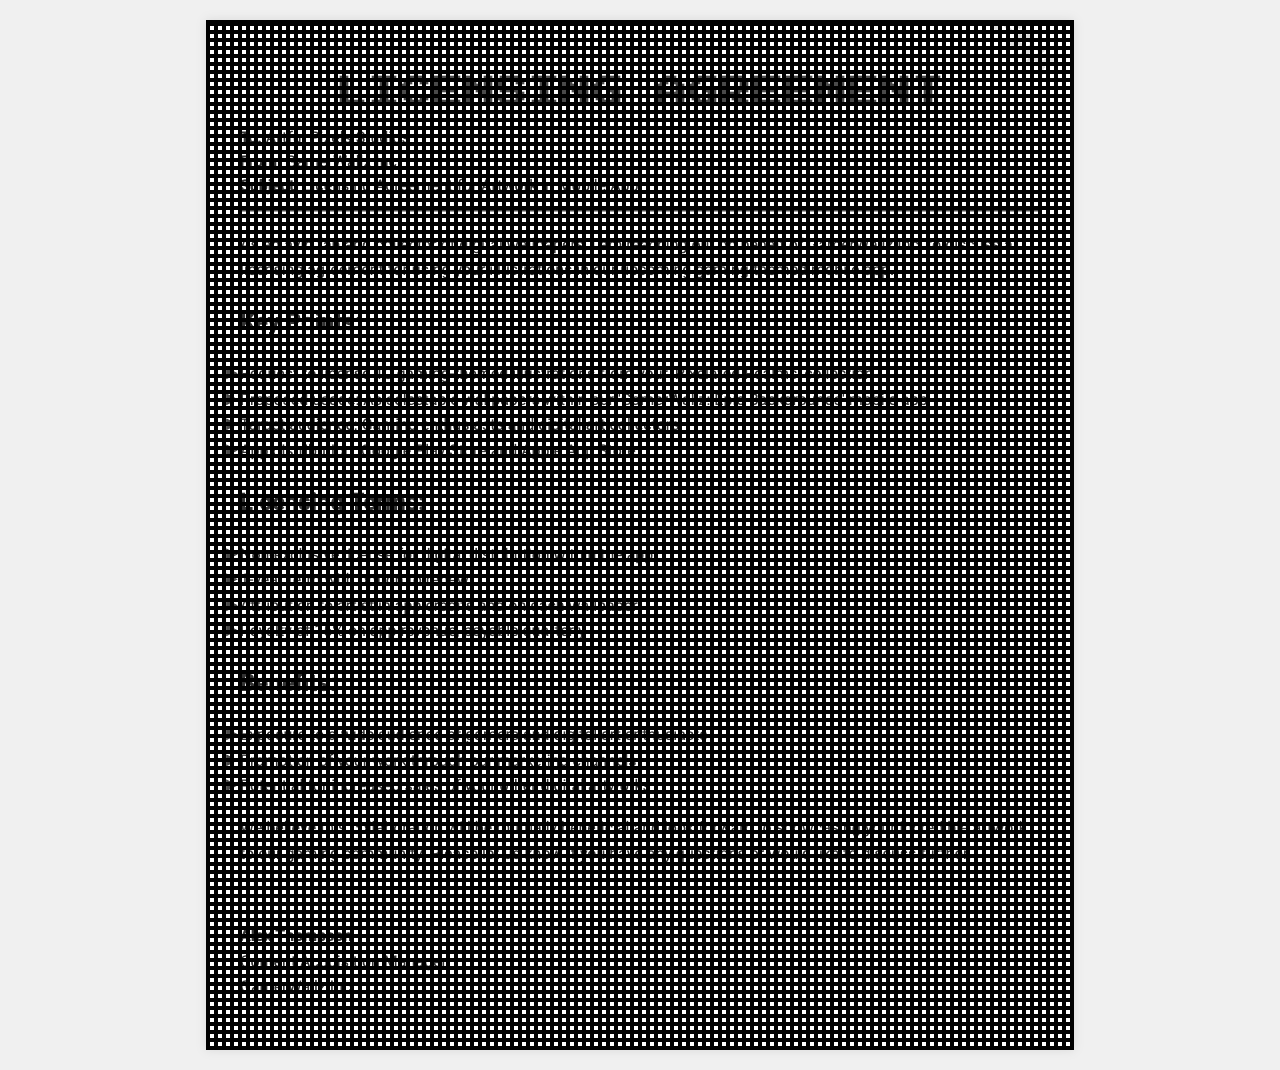What is the name of the studio? The studio's name is mentioned as Artful Pixels Studios in the 'To' section of the fax.
Answer: Artful Pixels Studios Who is the sender of the fax? The sender, listed in the 'From' section, is identified as GamerWallz Inc.
Answer: GamerWallz Inc How many illustrations are being requested for licensing? The document specifies that 10 illustrations are requested from the collection.
Answer: 10 What is the royalty percentage offered? The document states that the royalty percentage on app revenue is 15%.
Answer: 15% What is the duration of the licensing term? The licensing term is indicated as 1 year with an option to renew.
Answer: 1-year What is the target audience for the mobile app? The target audience is identified as gaming enthusiasts and digital art collectors.
Answer: Gaming enthusiasts and digital art collectors What is the name of the mobile app? The mobile app is titled 'GamerWallz: Epic Backgrounds.'
Answer: GamerWallz: Epic Backgrounds Who is the Content Acquisition Manager? The Content Acquisition Manager's name is provided at the end of the document.
Answer: Alex Thompson 